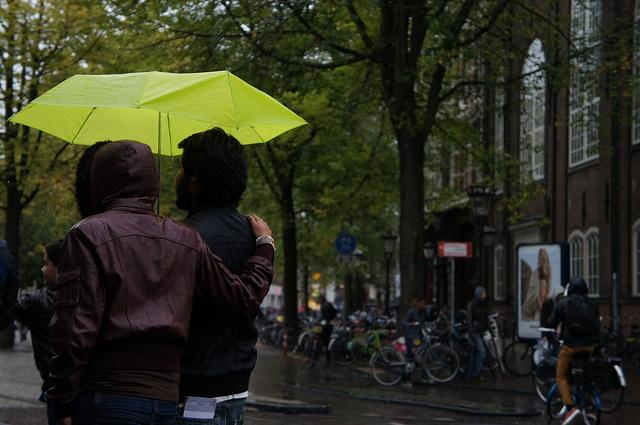Why are they using an umbrella? block rain 